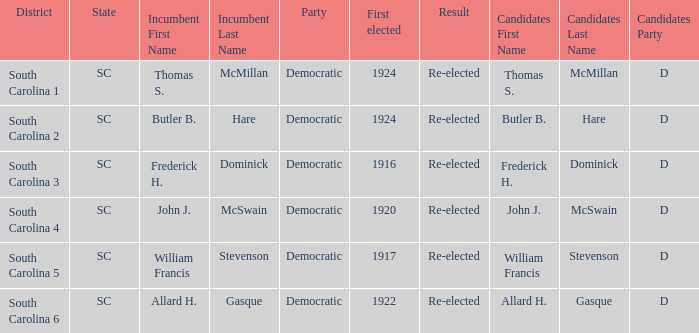Would you be able to parse every entry in this table? {'header': ['District', 'State', 'Incumbent First Name', 'Incumbent Last Name', 'Party', 'First elected', 'Result', 'Candidates First Name', 'Candidates Last Name', 'Candidates Party'], 'rows': [['South Carolina 1', 'SC', 'Thomas S.', 'McMillan', 'Democratic', '1924', 'Re-elected', 'Thomas S.', 'McMillan', 'D'], ['South Carolina 2', 'SC', 'Butler B.', 'Hare', 'Democratic', '1924', 'Re-elected', 'Butler B.', 'Hare', 'D'], ['South Carolina 3', 'SC', 'Frederick H.', 'Dominick', 'Democratic', '1916', 'Re-elected', 'Frederick H.', 'Dominick', 'D'], ['South Carolina 4', 'SC', 'John J.', 'McSwain', 'Democratic', '1920', 'Re-elected', 'John J.', 'McSwain', 'D'], ['South Carolina 5', 'SC', 'William Francis', 'Stevenson', 'Democratic', '1917', 'Re-elected', 'William Francis', 'Stevenson', 'D'], ['South Carolina 6', 'SC', 'Allard H.', 'Gasque', 'Democratic', '1922', 'Re-elected', 'Allard H.', 'Gasque', 'D']]} What was the year of william francis stevenson's first election win? 1917.0. 